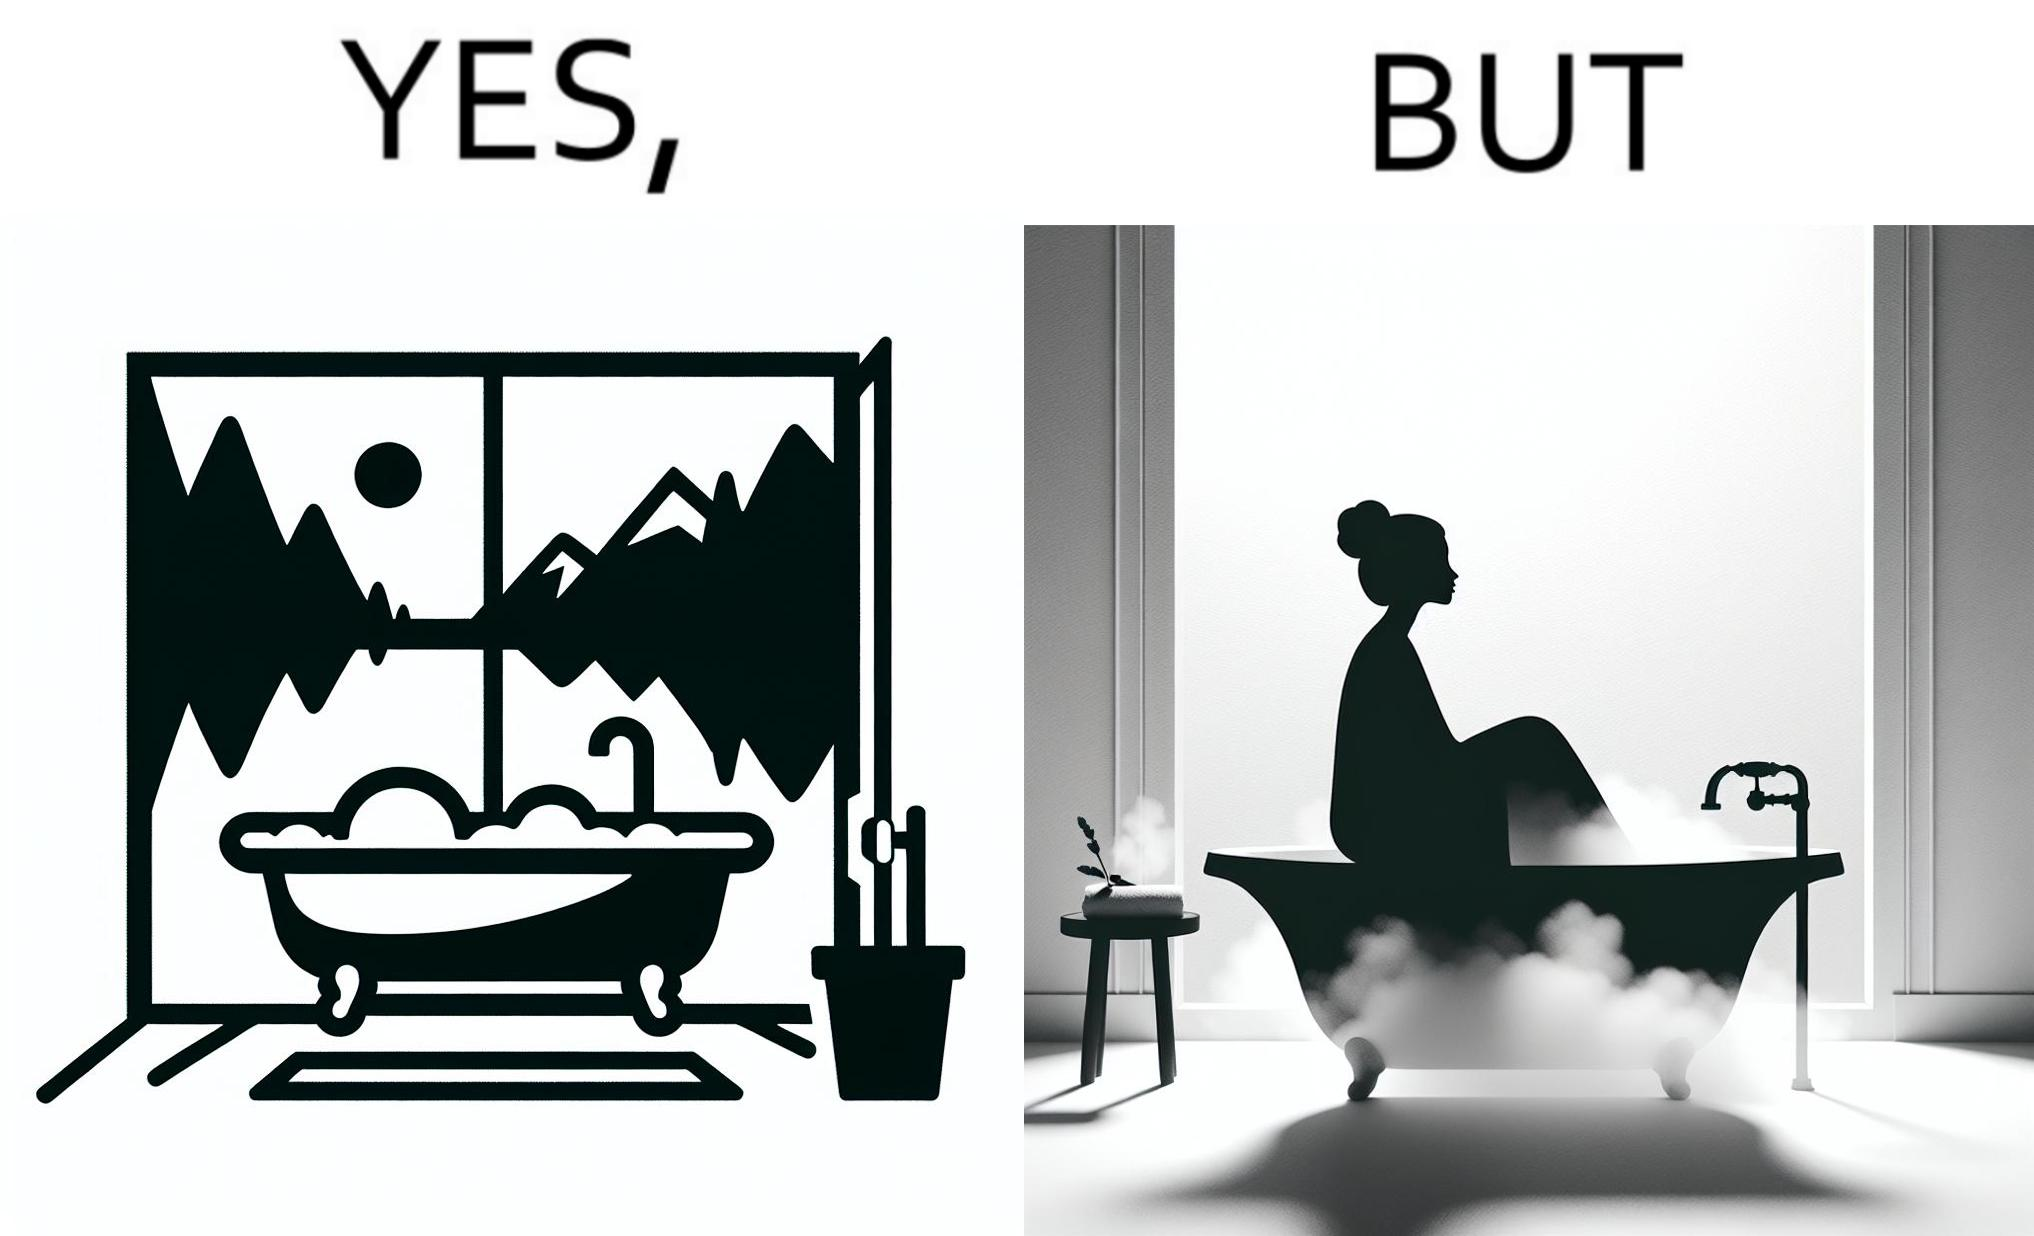Compare the left and right sides of this image. In the left part of the image: a bathtub by the side of a window which has a very scenic view of lake and mountains. In the right part of the image: a woman bathing in a bathtub, while the window glasses are foggy from the steam of the hot water. 